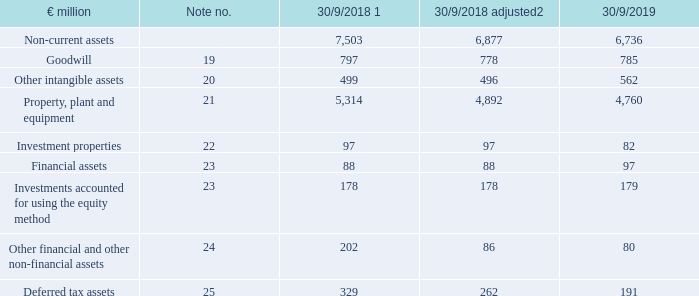Asset position
In financial year 2018/19, total assets of continuing and discontinued operations decreased by €709 million to €14.5 billion (30/9/2018: €15.2 billion).
In financial year 2018/19, non-current assets from continuing operations decreased by €141 million to €6.7 billion (30/9/2018: €6.9 billion), primarily relating to property, plant and equipment. In addition to cost-efficient investment activities, this was mainly due to individual property sales, while currency effects increased the carrying amount.
1 Adjustment of previous year according to explanation in notes.
2 Adjusted for effects of the discontinued business segment.
For more information about the development of non-current assets, see the notes to the consolidated financial statements in the numbers listed in the table.
What was the column '30/9/2018 adjusted' adjusted for? Adjusted for effects of the discontinued business segment. How much did the total assets of continuing and discontinued operations change by in FY2019? Decreased by €709 million to €14.5 billion (30/9/2018: €15.2 billion). In which years was the amount of non-current assets recorded in? 2019, 2018. What is the difference in Goodwill and other intangible assets for FY2019?
Answer scale should be: million.  785 - 562 
Answer: 223. What was the change in deferred tax assets in FY2019 from FY2018 adjusted?
Answer scale should be: million. 191-262
Answer: -71. What was the percentage change in deferred tax assets in FY2019 from FY2018 adjusted?
Answer scale should be: percent. (191-262)/262
Answer: -27.1. 